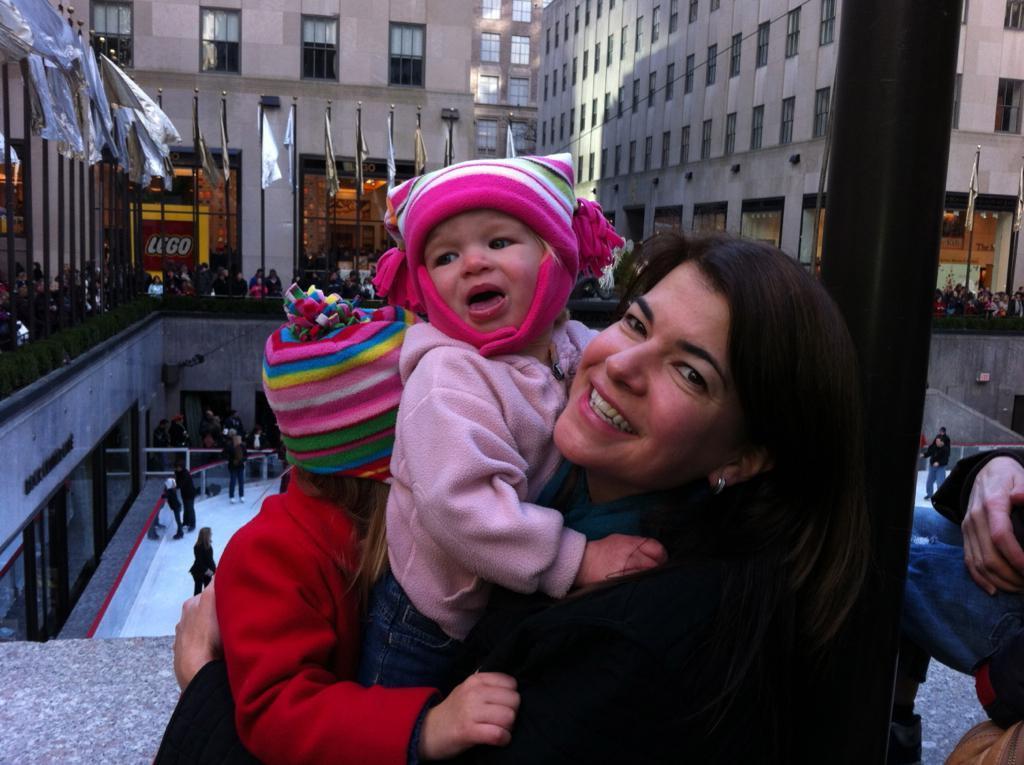Please provide a concise description of this image. In this image a woman is carrying children. In the background I can see people, flags, pole, buildings and other objects. 